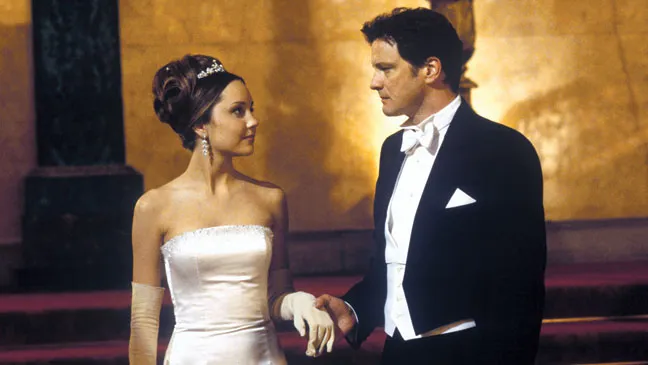What's happening in the scene? In this image, we see a scene from the movie "What a Girl Wants." The scene features Amanda Bynes and Colin Firth in a formal event setting. Amanda Bynes is dressed in a stunning white strapless gown, adorned with a tiara and elegant gloves, exuding a princess-like elegance. She is looking up at Colin Firth with a smile, capturing a moment of warmth and admiration. Colin Firth, in a classic black tuxedo with a white bowtie and waistcoat, looks down at her with a serious expression that might hint at the significance of their conversation. The gold-colored wall in the background adds a touch of grandeur to the scene, suggesting that the event they are attending is very important. 